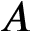<formula> <loc_0><loc_0><loc_500><loc_500>A</formula> 